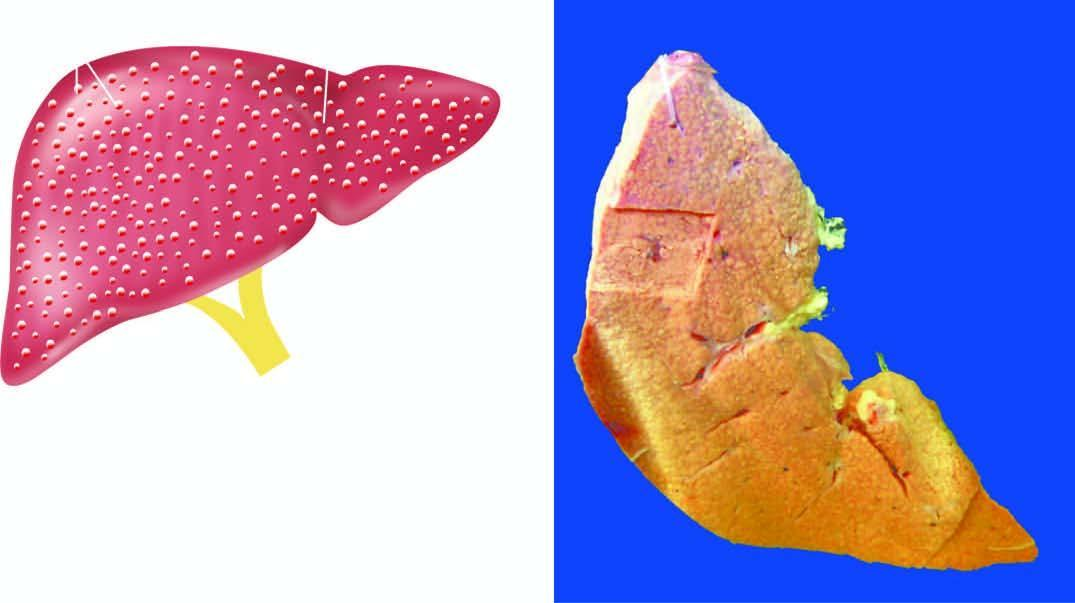where is diffuse nodularity?
Answer the question using a single word or phrase. On sectioned surface of the liver 